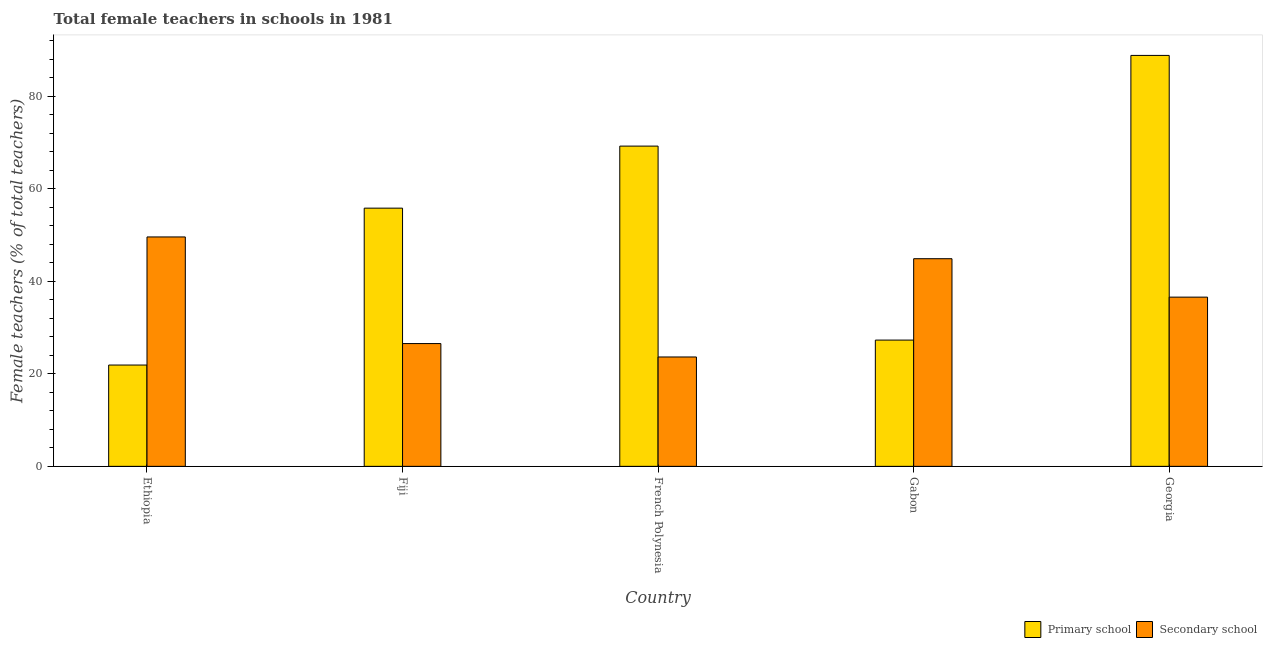Are the number of bars on each tick of the X-axis equal?
Offer a terse response. Yes. How many bars are there on the 1st tick from the right?
Your answer should be compact. 2. What is the label of the 2nd group of bars from the left?
Your response must be concise. Fiji. In how many cases, is the number of bars for a given country not equal to the number of legend labels?
Your response must be concise. 0. What is the percentage of female teachers in secondary schools in Fiji?
Offer a very short reply. 26.54. Across all countries, what is the maximum percentage of female teachers in secondary schools?
Offer a terse response. 49.58. Across all countries, what is the minimum percentage of female teachers in primary schools?
Offer a very short reply. 21.9. In which country was the percentage of female teachers in secondary schools maximum?
Your answer should be very brief. Ethiopia. In which country was the percentage of female teachers in secondary schools minimum?
Ensure brevity in your answer.  French Polynesia. What is the total percentage of female teachers in secondary schools in the graph?
Offer a terse response. 181.21. What is the difference between the percentage of female teachers in primary schools in Ethiopia and that in Fiji?
Give a very brief answer. -33.91. What is the difference between the percentage of female teachers in primary schools in Gabon and the percentage of female teachers in secondary schools in Ethiopia?
Make the answer very short. -22.29. What is the average percentage of female teachers in secondary schools per country?
Make the answer very short. 36.24. What is the difference between the percentage of female teachers in secondary schools and percentage of female teachers in primary schools in Georgia?
Ensure brevity in your answer.  -52.24. What is the ratio of the percentage of female teachers in secondary schools in Ethiopia to that in Fiji?
Keep it short and to the point. 1.87. Is the difference between the percentage of female teachers in primary schools in Fiji and Gabon greater than the difference between the percentage of female teachers in secondary schools in Fiji and Gabon?
Make the answer very short. Yes. What is the difference between the highest and the second highest percentage of female teachers in secondary schools?
Ensure brevity in your answer.  4.71. What is the difference between the highest and the lowest percentage of female teachers in primary schools?
Offer a terse response. 66.92. Is the sum of the percentage of female teachers in primary schools in Fiji and Gabon greater than the maximum percentage of female teachers in secondary schools across all countries?
Offer a very short reply. Yes. What does the 1st bar from the left in Georgia represents?
Your answer should be compact. Primary school. What does the 1st bar from the right in French Polynesia represents?
Offer a terse response. Secondary school. Are all the bars in the graph horizontal?
Offer a terse response. No. How many countries are there in the graph?
Provide a short and direct response. 5. What is the difference between two consecutive major ticks on the Y-axis?
Make the answer very short. 20. Are the values on the major ticks of Y-axis written in scientific E-notation?
Make the answer very short. No. Does the graph contain grids?
Your answer should be compact. No. How are the legend labels stacked?
Ensure brevity in your answer.  Horizontal. What is the title of the graph?
Keep it short and to the point. Total female teachers in schools in 1981. What is the label or title of the Y-axis?
Keep it short and to the point. Female teachers (% of total teachers). What is the Female teachers (% of total teachers) in Primary school in Ethiopia?
Offer a very short reply. 21.9. What is the Female teachers (% of total teachers) of Secondary school in Ethiopia?
Your answer should be compact. 49.58. What is the Female teachers (% of total teachers) in Primary school in Fiji?
Offer a very short reply. 55.81. What is the Female teachers (% of total teachers) in Secondary school in Fiji?
Offer a terse response. 26.54. What is the Female teachers (% of total teachers) in Primary school in French Polynesia?
Your answer should be compact. 69.22. What is the Female teachers (% of total teachers) in Secondary school in French Polynesia?
Make the answer very short. 23.64. What is the Female teachers (% of total teachers) of Primary school in Gabon?
Your response must be concise. 27.29. What is the Female teachers (% of total teachers) in Secondary school in Gabon?
Make the answer very short. 44.88. What is the Female teachers (% of total teachers) in Primary school in Georgia?
Offer a very short reply. 88.82. What is the Female teachers (% of total teachers) of Secondary school in Georgia?
Offer a very short reply. 36.57. Across all countries, what is the maximum Female teachers (% of total teachers) of Primary school?
Ensure brevity in your answer.  88.82. Across all countries, what is the maximum Female teachers (% of total teachers) of Secondary school?
Offer a terse response. 49.58. Across all countries, what is the minimum Female teachers (% of total teachers) in Primary school?
Your answer should be compact. 21.9. Across all countries, what is the minimum Female teachers (% of total teachers) in Secondary school?
Your answer should be very brief. 23.64. What is the total Female teachers (% of total teachers) in Primary school in the graph?
Your answer should be compact. 263.02. What is the total Female teachers (% of total teachers) in Secondary school in the graph?
Make the answer very short. 181.21. What is the difference between the Female teachers (% of total teachers) in Primary school in Ethiopia and that in Fiji?
Give a very brief answer. -33.91. What is the difference between the Female teachers (% of total teachers) of Secondary school in Ethiopia and that in Fiji?
Provide a short and direct response. 23.05. What is the difference between the Female teachers (% of total teachers) in Primary school in Ethiopia and that in French Polynesia?
Give a very brief answer. -47.32. What is the difference between the Female teachers (% of total teachers) of Secondary school in Ethiopia and that in French Polynesia?
Provide a short and direct response. 25.94. What is the difference between the Female teachers (% of total teachers) of Primary school in Ethiopia and that in Gabon?
Your answer should be very brief. -5.39. What is the difference between the Female teachers (% of total teachers) of Secondary school in Ethiopia and that in Gabon?
Give a very brief answer. 4.71. What is the difference between the Female teachers (% of total teachers) in Primary school in Ethiopia and that in Georgia?
Provide a short and direct response. -66.92. What is the difference between the Female teachers (% of total teachers) in Secondary school in Ethiopia and that in Georgia?
Ensure brevity in your answer.  13.01. What is the difference between the Female teachers (% of total teachers) in Primary school in Fiji and that in French Polynesia?
Ensure brevity in your answer.  -13.41. What is the difference between the Female teachers (% of total teachers) in Secondary school in Fiji and that in French Polynesia?
Ensure brevity in your answer.  2.9. What is the difference between the Female teachers (% of total teachers) in Primary school in Fiji and that in Gabon?
Your response must be concise. 28.52. What is the difference between the Female teachers (% of total teachers) in Secondary school in Fiji and that in Gabon?
Provide a short and direct response. -18.34. What is the difference between the Female teachers (% of total teachers) in Primary school in Fiji and that in Georgia?
Keep it short and to the point. -33.01. What is the difference between the Female teachers (% of total teachers) in Secondary school in Fiji and that in Georgia?
Offer a very short reply. -10.04. What is the difference between the Female teachers (% of total teachers) in Primary school in French Polynesia and that in Gabon?
Offer a very short reply. 41.93. What is the difference between the Female teachers (% of total teachers) of Secondary school in French Polynesia and that in Gabon?
Provide a succinct answer. -21.24. What is the difference between the Female teachers (% of total teachers) in Primary school in French Polynesia and that in Georgia?
Ensure brevity in your answer.  -19.6. What is the difference between the Female teachers (% of total teachers) of Secondary school in French Polynesia and that in Georgia?
Provide a succinct answer. -12.93. What is the difference between the Female teachers (% of total teachers) of Primary school in Gabon and that in Georgia?
Your answer should be very brief. -61.53. What is the difference between the Female teachers (% of total teachers) of Secondary school in Gabon and that in Georgia?
Offer a terse response. 8.3. What is the difference between the Female teachers (% of total teachers) of Primary school in Ethiopia and the Female teachers (% of total teachers) of Secondary school in Fiji?
Your answer should be compact. -4.64. What is the difference between the Female teachers (% of total teachers) of Primary school in Ethiopia and the Female teachers (% of total teachers) of Secondary school in French Polynesia?
Keep it short and to the point. -1.74. What is the difference between the Female teachers (% of total teachers) in Primary school in Ethiopia and the Female teachers (% of total teachers) in Secondary school in Gabon?
Ensure brevity in your answer.  -22.98. What is the difference between the Female teachers (% of total teachers) of Primary school in Ethiopia and the Female teachers (% of total teachers) of Secondary school in Georgia?
Keep it short and to the point. -14.68. What is the difference between the Female teachers (% of total teachers) of Primary school in Fiji and the Female teachers (% of total teachers) of Secondary school in French Polynesia?
Offer a very short reply. 32.17. What is the difference between the Female teachers (% of total teachers) of Primary school in Fiji and the Female teachers (% of total teachers) of Secondary school in Gabon?
Your answer should be very brief. 10.93. What is the difference between the Female teachers (% of total teachers) in Primary school in Fiji and the Female teachers (% of total teachers) in Secondary school in Georgia?
Offer a terse response. 19.24. What is the difference between the Female teachers (% of total teachers) of Primary school in French Polynesia and the Female teachers (% of total teachers) of Secondary school in Gabon?
Ensure brevity in your answer.  24.34. What is the difference between the Female teachers (% of total teachers) in Primary school in French Polynesia and the Female teachers (% of total teachers) in Secondary school in Georgia?
Provide a short and direct response. 32.64. What is the difference between the Female teachers (% of total teachers) of Primary school in Gabon and the Female teachers (% of total teachers) of Secondary school in Georgia?
Give a very brief answer. -9.28. What is the average Female teachers (% of total teachers) of Primary school per country?
Ensure brevity in your answer.  52.6. What is the average Female teachers (% of total teachers) of Secondary school per country?
Your response must be concise. 36.24. What is the difference between the Female teachers (% of total teachers) of Primary school and Female teachers (% of total teachers) of Secondary school in Ethiopia?
Keep it short and to the point. -27.69. What is the difference between the Female teachers (% of total teachers) in Primary school and Female teachers (% of total teachers) in Secondary school in Fiji?
Your answer should be very brief. 29.27. What is the difference between the Female teachers (% of total teachers) in Primary school and Female teachers (% of total teachers) in Secondary school in French Polynesia?
Provide a short and direct response. 45.58. What is the difference between the Female teachers (% of total teachers) in Primary school and Female teachers (% of total teachers) in Secondary school in Gabon?
Offer a terse response. -17.59. What is the difference between the Female teachers (% of total teachers) in Primary school and Female teachers (% of total teachers) in Secondary school in Georgia?
Your answer should be very brief. 52.24. What is the ratio of the Female teachers (% of total teachers) of Primary school in Ethiopia to that in Fiji?
Provide a succinct answer. 0.39. What is the ratio of the Female teachers (% of total teachers) of Secondary school in Ethiopia to that in Fiji?
Your answer should be compact. 1.87. What is the ratio of the Female teachers (% of total teachers) in Primary school in Ethiopia to that in French Polynesia?
Offer a very short reply. 0.32. What is the ratio of the Female teachers (% of total teachers) in Secondary school in Ethiopia to that in French Polynesia?
Provide a succinct answer. 2.1. What is the ratio of the Female teachers (% of total teachers) of Primary school in Ethiopia to that in Gabon?
Provide a succinct answer. 0.8. What is the ratio of the Female teachers (% of total teachers) of Secondary school in Ethiopia to that in Gabon?
Keep it short and to the point. 1.1. What is the ratio of the Female teachers (% of total teachers) in Primary school in Ethiopia to that in Georgia?
Offer a very short reply. 0.25. What is the ratio of the Female teachers (% of total teachers) of Secondary school in Ethiopia to that in Georgia?
Make the answer very short. 1.36. What is the ratio of the Female teachers (% of total teachers) of Primary school in Fiji to that in French Polynesia?
Your response must be concise. 0.81. What is the ratio of the Female teachers (% of total teachers) of Secondary school in Fiji to that in French Polynesia?
Your answer should be compact. 1.12. What is the ratio of the Female teachers (% of total teachers) in Primary school in Fiji to that in Gabon?
Your answer should be compact. 2.05. What is the ratio of the Female teachers (% of total teachers) in Secondary school in Fiji to that in Gabon?
Your answer should be very brief. 0.59. What is the ratio of the Female teachers (% of total teachers) of Primary school in Fiji to that in Georgia?
Your response must be concise. 0.63. What is the ratio of the Female teachers (% of total teachers) in Secondary school in Fiji to that in Georgia?
Give a very brief answer. 0.73. What is the ratio of the Female teachers (% of total teachers) of Primary school in French Polynesia to that in Gabon?
Your answer should be very brief. 2.54. What is the ratio of the Female teachers (% of total teachers) of Secondary school in French Polynesia to that in Gabon?
Your response must be concise. 0.53. What is the ratio of the Female teachers (% of total teachers) of Primary school in French Polynesia to that in Georgia?
Your response must be concise. 0.78. What is the ratio of the Female teachers (% of total teachers) of Secondary school in French Polynesia to that in Georgia?
Give a very brief answer. 0.65. What is the ratio of the Female teachers (% of total teachers) in Primary school in Gabon to that in Georgia?
Offer a very short reply. 0.31. What is the ratio of the Female teachers (% of total teachers) of Secondary school in Gabon to that in Georgia?
Your answer should be compact. 1.23. What is the difference between the highest and the second highest Female teachers (% of total teachers) in Primary school?
Your answer should be compact. 19.6. What is the difference between the highest and the second highest Female teachers (% of total teachers) in Secondary school?
Offer a terse response. 4.71. What is the difference between the highest and the lowest Female teachers (% of total teachers) in Primary school?
Offer a very short reply. 66.92. What is the difference between the highest and the lowest Female teachers (% of total teachers) in Secondary school?
Make the answer very short. 25.94. 